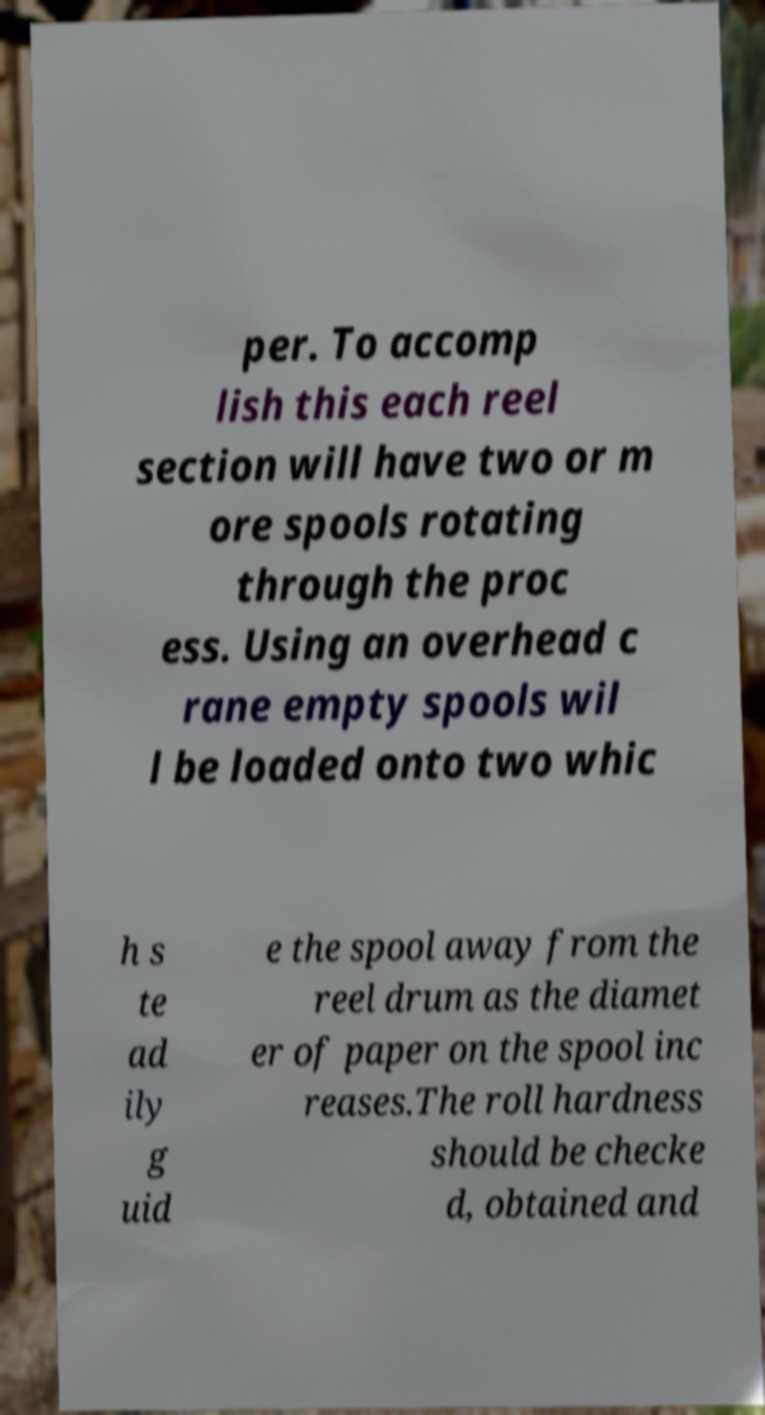For documentation purposes, I need the text within this image transcribed. Could you provide that? per. To accomp lish this each reel section will have two or m ore spools rotating through the proc ess. Using an overhead c rane empty spools wil l be loaded onto two whic h s te ad ily g uid e the spool away from the reel drum as the diamet er of paper on the spool inc reases.The roll hardness should be checke d, obtained and 